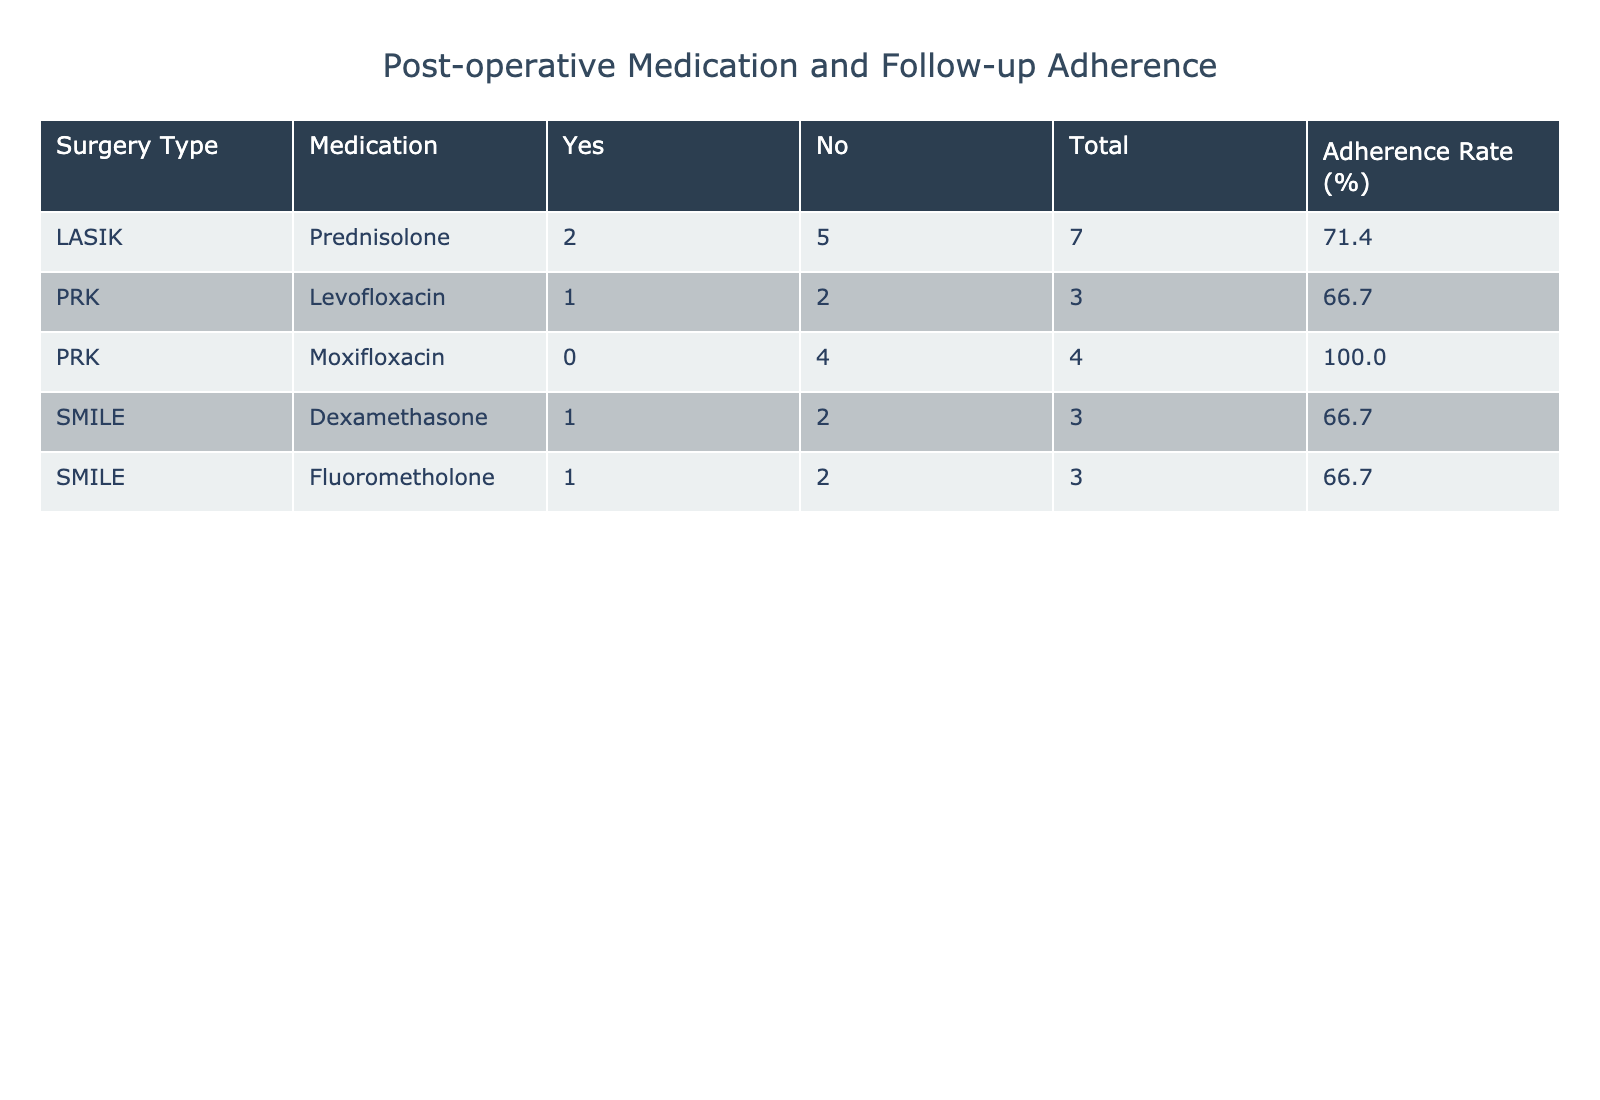What is the adherence rate for patients who had LASIK surgery with Prednisolone medication? From the table, we see that there are 5 patients who had LASIK surgery with Prednisolone. Out of these, 4 patients adhered to the follow-up appointments (Yes) and 1 did not (No). To find the adherence rate, we calculate (4/5) * 100 = 80%.
Answer: 80% How many patients took Moxifloxacin but did not adhere to follow-up appointments? We look at the rows related to Moxifloxacin. There are 4 patients in total. Among them, 3 adhered to follow-up appointments (Yes) and 1 did not (No). Therefore, there is 1 patient who did not adhere.
Answer: 1 What is the total number of patients who had SMILE surgery and their follow-up was not adhered? There are 4 patients who had SMILE surgery. Out of these, 2 did not adhere to their follow-up appointments (No). Adding them gives a total of 2 patients who did not adhere.
Answer: 2 Is there any case of complications reported for patients who adhered to their follow-up appointments? We can filter the table for patients with "Yes" in the Follow-up Adherence column. Upon looking through the details, the complications reported amongst them are: None, Mild Discomfort, Mild Pain. Hence, none of the patients who adhered had serious complications recorded.
Answer: No What is the average days to the first follow-up appointment for patients who took Levofloxacin? There are 3 patients who took Levofloxacin, and their respective days to the first follow-up are 10, 2, and 3. To find the average, we sum these numbers: (10 + 2 + 3) = 15, then divide by 3, which gives us an average of 5 days.
Answer: 5 What percentage of patients who had PRK surgery adhered to their follow-up appointments? First, we look at the patients with PRK surgery. There are 6 in total with a breakdown of 4 adhering (Yes) and 2 not adhering (No). The percentage can be calculated as (4/6) * 100, which equals approximately 66.67%.
Answer: 66.67% How many patients in total reported complications? We check each row to identify patients who reported complications. From the data, 4 patients reported complications: Mild Discomfort, Mild Pain, Infection, and Delayed Healing. Thus, the total number of patients with complications is 4.
Answer: 4 What type of surgery had the highest follow-up adherence rate? We evaluate each type of surgery. LASIK has 4 patients adhering out of 5 (80%), PRK has 4 out of 6 (66.67%) and SMILE has 2 out of 4 (50%). Thus, LASIK has the highest adherence rate at 80%.
Answer: LASIK 